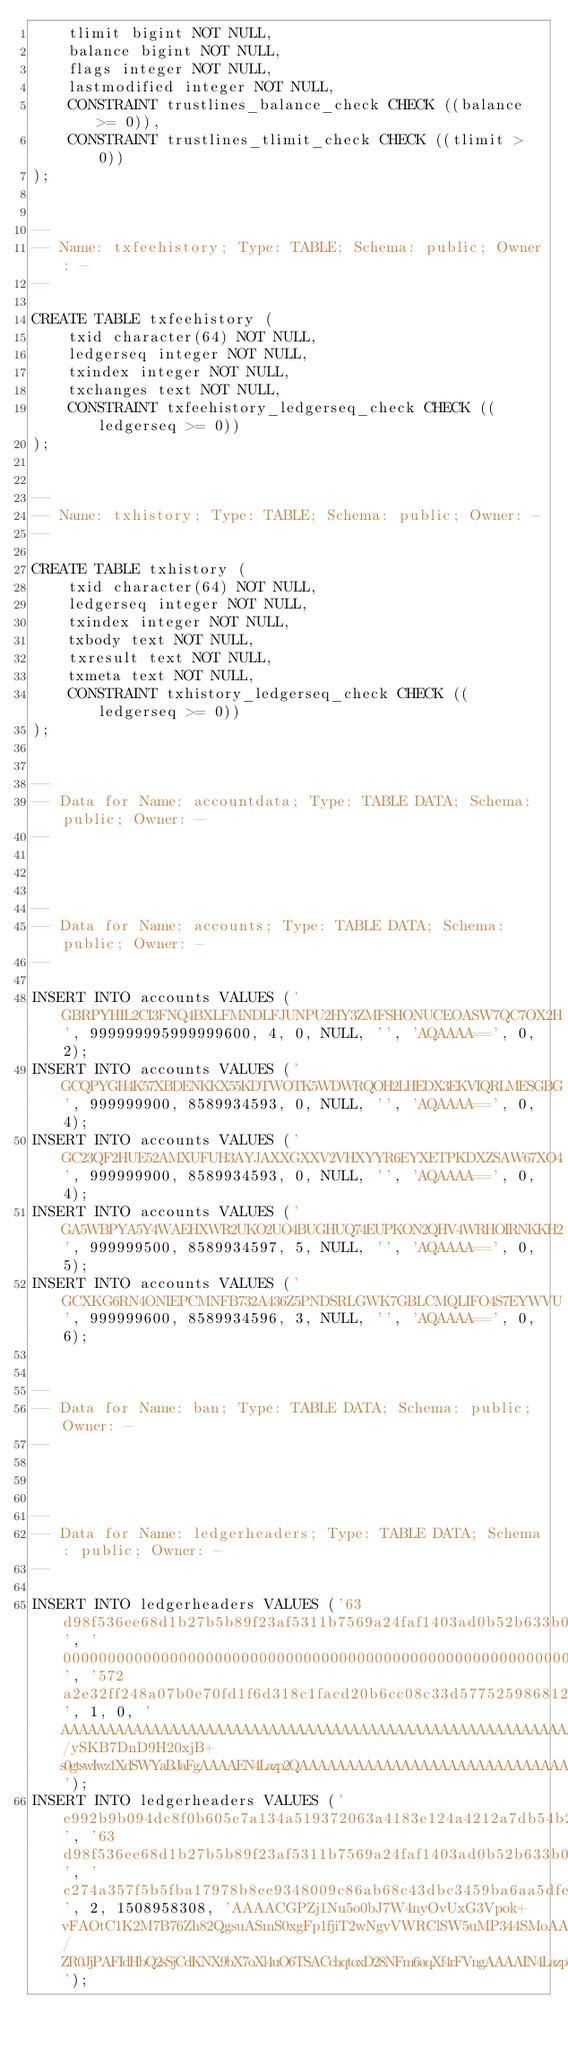<code> <loc_0><loc_0><loc_500><loc_500><_SQL_>    tlimit bigint NOT NULL,
    balance bigint NOT NULL,
    flags integer NOT NULL,
    lastmodified integer NOT NULL,
    CONSTRAINT trustlines_balance_check CHECK ((balance >= 0)),
    CONSTRAINT trustlines_tlimit_check CHECK ((tlimit > 0))
);


--
-- Name: txfeehistory; Type: TABLE; Schema: public; Owner: -
--

CREATE TABLE txfeehistory (
    txid character(64) NOT NULL,
    ledgerseq integer NOT NULL,
    txindex integer NOT NULL,
    txchanges text NOT NULL,
    CONSTRAINT txfeehistory_ledgerseq_check CHECK ((ledgerseq >= 0))
);


--
-- Name: txhistory; Type: TABLE; Schema: public; Owner: -
--

CREATE TABLE txhistory (
    txid character(64) NOT NULL,
    ledgerseq integer NOT NULL,
    txindex integer NOT NULL,
    txbody text NOT NULL,
    txresult text NOT NULL,
    txmeta text NOT NULL,
    CONSTRAINT txhistory_ledgerseq_check CHECK ((ledgerseq >= 0))
);


--
-- Data for Name: accountdata; Type: TABLE DATA; Schema: public; Owner: -
--



--
-- Data for Name: accounts; Type: TABLE DATA; Schema: public; Owner: -
--

INSERT INTO accounts VALUES ('GBRPYHIL2CI3FNQ4BXLFMNDLFJUNPU2HY3ZMFSHONUCEOASW7QC7OX2H', 999999995999999600, 4, 0, NULL, '', 'AQAAAA==', 0, 2);
INSERT INTO accounts VALUES ('GCQPYGH4K57XBDENKKX55KDTWOTK5WDWRQOH2LHEDX3EKVIQRLMESGBG', 999999900, 8589934593, 0, NULL, '', 'AQAAAA==', 0, 4);
INSERT INTO accounts VALUES ('GC23QF2HUE52AMXUFUH3AYJAXXGXXV2VHXYYR6EYXETPKDXZSAW67XO4', 999999900, 8589934593, 0, NULL, '', 'AQAAAA==', 0, 4);
INSERT INTO accounts VALUES ('GA5WBPYA5Y4WAEHXWR2UKO2UO4BUGHUQ74EUPKON2QHV4WRHOIRNKKH2', 999999500, 8589934597, 5, NULL, '', 'AQAAAA==', 0, 5);
INSERT INTO accounts VALUES ('GCXKG6RN4ONIEPCMNFB732A436Z5PNDSRLGWK7GBLCMQLIFO4S7EYWVU', 999999600, 8589934596, 3, NULL, '', 'AQAAAA==', 0, 6);


--
-- Data for Name: ban; Type: TABLE DATA; Schema: public; Owner: -
--



--
-- Data for Name: ledgerheaders; Type: TABLE DATA; Schema: public; Owner: -
--

INSERT INTO ledgerheaders VALUES ('63d98f536ee68d1b27b5b89f23af5311b7569a24faf1403ad0b52b633b07be99', '0000000000000000000000000000000000000000000000000000000000000000', '572a2e32ff248a07b0e70fd1f6d318c1facd20b6cc08c33d5775259868125a16', 1, 0, 'AAAAAAAAAAAAAAAAAAAAAAAAAAAAAAAAAAAAAAAAAAAAAAAAAAAAAAAAAAAAAAAAAAAAAAAAAAAAAAAAAAAAAAAAAAAAAAAAAAAAAAAAAAAAAAAAAAAAAAAAAAAAAAAAAAAAAAAAAAAAAAAAAAAAAAAAAABXKi4y/ySKB7DnD9H20xjB+s0gtswIwz1XdSWYaBJaFgAAAAEN4Lazp2QAAAAAAAAAAAAAAAAAAAAAAAAAAAAAAAAAZAX14QAAAABkAAAAAAAAAAAAAAAAAAAAAAAAAAAAAAAAAAAAAAAAAAAAAAAAAAAAAAAAAAAAAAAAAAAAAAAAAAAAAAAAAAAAAAAAAAAAAAAAAAAAAAAAAAAAAAAAAAAAAAAAAAAAAAAAAAAAAAAAAAAAAAAAAAAAAAAAAAAAAAAAAAAAAAAAAAAAAAAA');
INSERT INTO ledgerheaders VALUES ('e992b9b094dc8f0b605e7a134a519372063a4183e124a4212a7db54b24a86ef3', '63d98f536ee68d1b27b5b89f23af5311b7569a24faf1403ad0b52b633b07be99', 'c274a357f5b5fba17978b8ee9348009c86ab68c43dbc3459ba6aa5dfe2b1559e', 2, 1508958308, 'AAAACGPZj1Nu5o0bJ7W4nyOvUxG3Vpok+vFAOtC1K2M7B76Zh82QgsuASmS0xgFp1fjiT2wNgvVWRClSW5uMP344SMoAAAAAWfDgZAAAAAIAAAAIAAAAAQAAAAgAAAAIAAAAAwAAJxAAAAAAh7rHH3ehqvUsWEPfAlvVspAA2/ZR0JjPAFIdHbQ2sSjCdKNX9bX7oXl4uO6TSACchqtoxD28NFm6aqXf4rFVngAAAAIN4Lazp2QAAAAAAAAAAAGQAAAAAAAAAAAAAAAAAAAAZAX14QAAACcQAAAAAAAAAAAAAAAAAAAAAAAAAAAAAAAAAAAAAAAAAAAAAAAAAAAAAAAAAAAAAAAAAAAAAAAAAAAAAAAAAAAAAAAAAAAAAAAAAAAAAAAAAAAAAAAAAAAAAAAAAAAAAAAAAAAAAAAAAAAAAAAAAAAAAAAAAAAAAAAAAAAAAAAAAAAAAAAA');</code> 